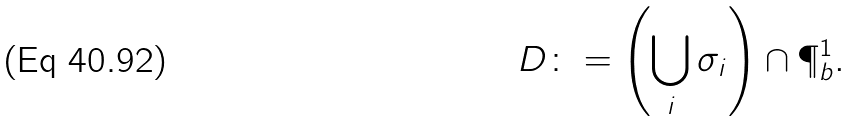Convert formula to latex. <formula><loc_0><loc_0><loc_500><loc_500>D \colon = \left ( \bigcup _ { i } \sigma _ { i } \right ) \cap \P ^ { 1 } _ { b } .</formula> 